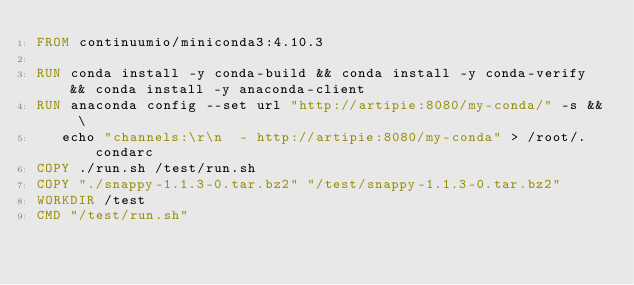<code> <loc_0><loc_0><loc_500><loc_500><_Dockerfile_>FROM continuumio/miniconda3:4.10.3

RUN conda install -y conda-build && conda install -y conda-verify && conda install -y anaconda-client
RUN anaconda config --set url "http://artipie:8080/my-conda/" -s && \
   echo "channels:\r\n  - http://artipie:8080/my-conda" > /root/.condarc
COPY ./run.sh /test/run.sh
COPY "./snappy-1.1.3-0.tar.bz2" "/test/snappy-1.1.3-0.tar.bz2"
WORKDIR /test
CMD "/test/run.sh"
</code> 